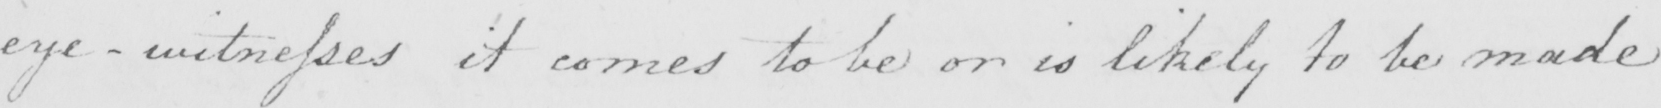Can you tell me what this handwritten text says? eye-witnesses it comes to be or is likely to be made 